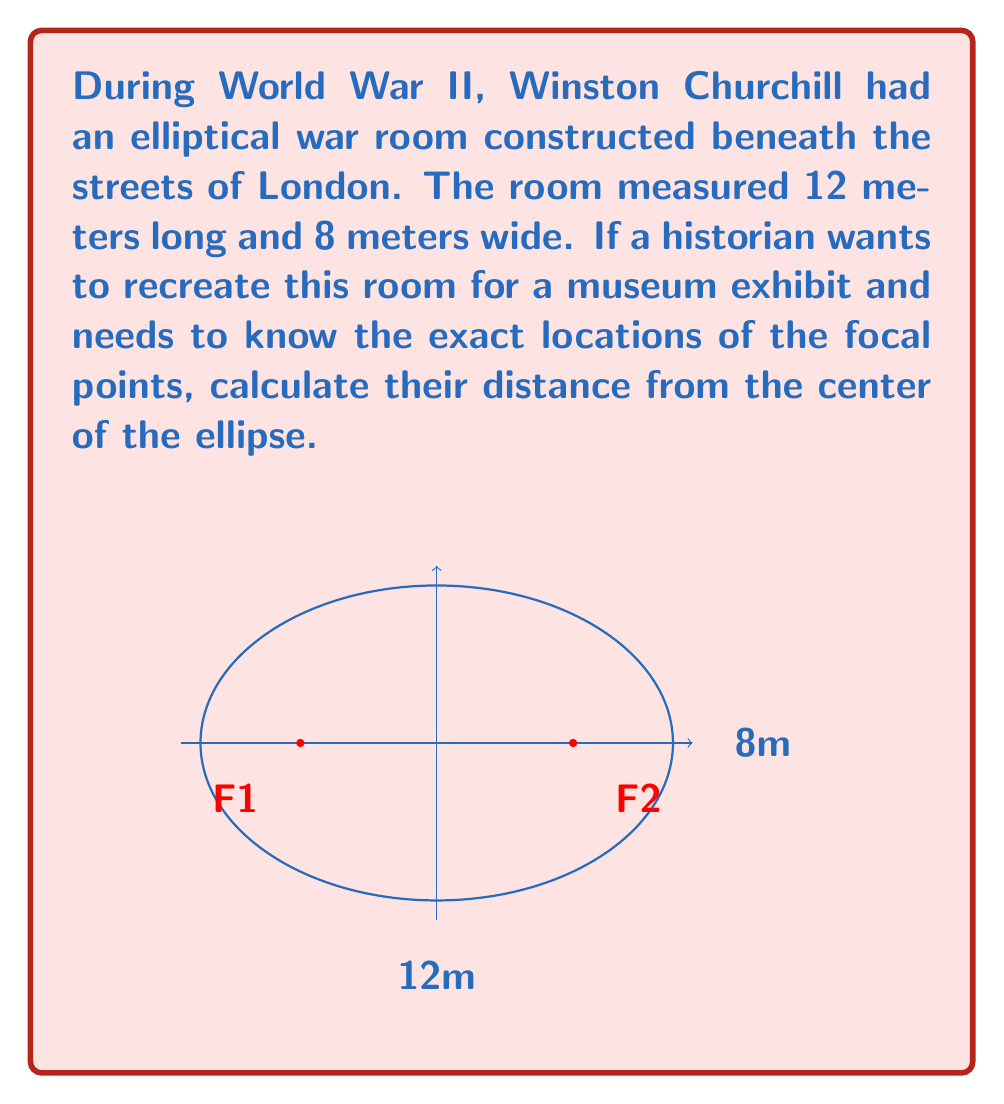Provide a solution to this math problem. To find the focal points of an elliptical room, we need to follow these steps:

1) First, recall the equation for an ellipse: $\frac{x^2}{a^2} + \frac{y^2}{b^2} = 1$, where $a$ is the semi-major axis and $b$ is the semi-minor axis.

2) In this case, $a = 6$ meters (half of 12m) and $b = 4$ meters (half of 8m).

3) The distance from the center to a focal point, let's call it $c$, is given by the equation: $c^2 = a^2 - b^2$

4) Substituting our values:

   $c^2 = 6^2 - 4^2$
   $c^2 = 36 - 16 = 20$

5) Taking the square root of both sides:

   $c = \sqrt{20} = 2\sqrt{5}$ meters

Therefore, the focal points are located $2\sqrt{5}$ meters to the left and right of the center of the ellipse along the major axis.
Answer: $2\sqrt{5}$ meters from the center 